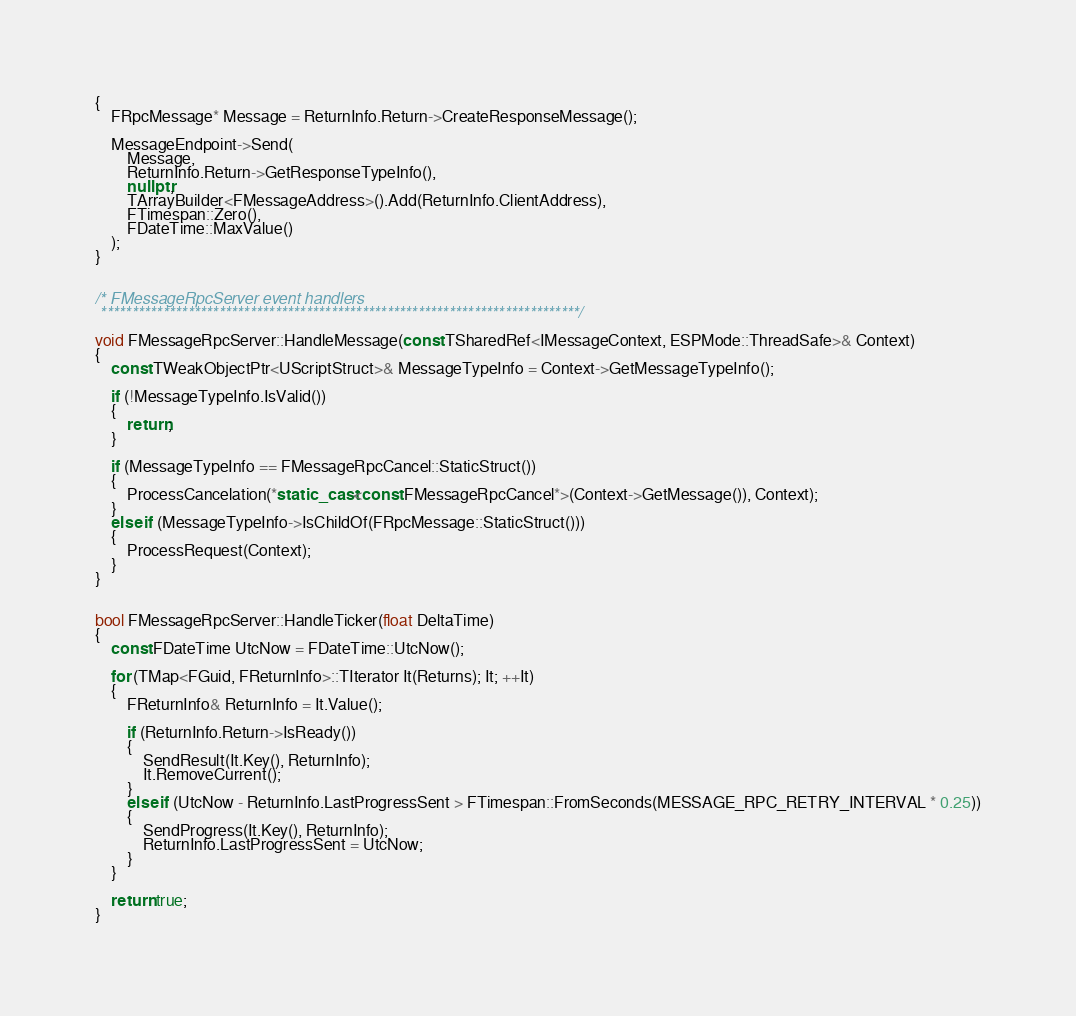Convert code to text. <code><loc_0><loc_0><loc_500><loc_500><_C++_>{
	FRpcMessage* Message = ReturnInfo.Return->CreateResponseMessage();

	MessageEndpoint->Send(
		Message,
		ReturnInfo.Return->GetResponseTypeInfo(),
		nullptr,
		TArrayBuilder<FMessageAddress>().Add(ReturnInfo.ClientAddress),
		FTimespan::Zero(),
		FDateTime::MaxValue()
	);
}


/* FMessageRpcServer event handlers
 *****************************************************************************/

void FMessageRpcServer::HandleMessage(const TSharedRef<IMessageContext, ESPMode::ThreadSafe>& Context)
{
	const TWeakObjectPtr<UScriptStruct>& MessageTypeInfo = Context->GetMessageTypeInfo();

	if (!MessageTypeInfo.IsValid())
	{
		return;
	}

	if (MessageTypeInfo == FMessageRpcCancel::StaticStruct())
	{
		ProcessCancelation(*static_cast<const FMessageRpcCancel*>(Context->GetMessage()), Context);
	}
	else if (MessageTypeInfo->IsChildOf(FRpcMessage::StaticStruct()))
	{
		ProcessRequest(Context);
	}
}


bool FMessageRpcServer::HandleTicker(float DeltaTime)
{
	const FDateTime UtcNow = FDateTime::UtcNow();

	for (TMap<FGuid, FReturnInfo>::TIterator It(Returns); It; ++It)
	{
		FReturnInfo& ReturnInfo = It.Value();

		if (ReturnInfo.Return->IsReady())
		{
			SendResult(It.Key(), ReturnInfo);
			It.RemoveCurrent();
		}
		else if (UtcNow - ReturnInfo.LastProgressSent > FTimespan::FromSeconds(MESSAGE_RPC_RETRY_INTERVAL * 0.25))
		{
			SendProgress(It.Key(), ReturnInfo);
			ReturnInfo.LastProgressSent = UtcNow;
		}
	}

	return true;
}
</code> 